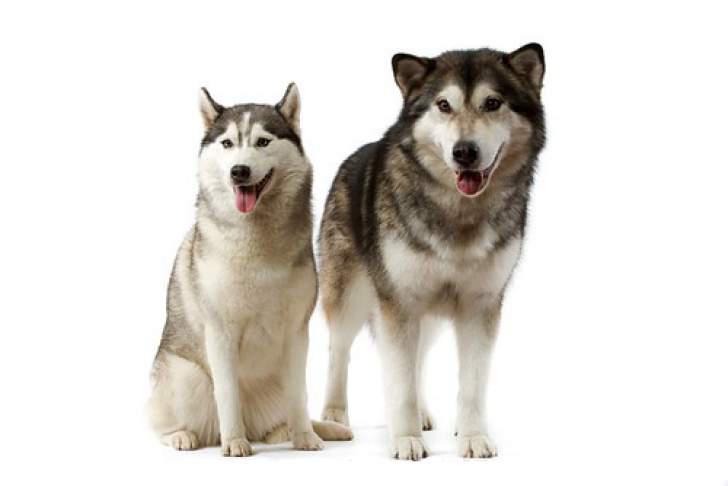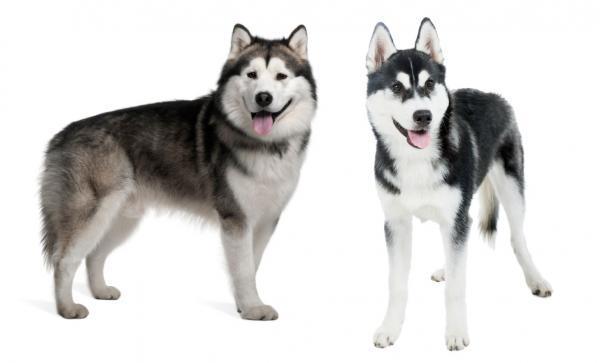The first image is the image on the left, the second image is the image on the right. Considering the images on both sides, is "In one image there is one dog, and in the other image there are two dogs that are the same breed." valid? Answer yes or no. No. 